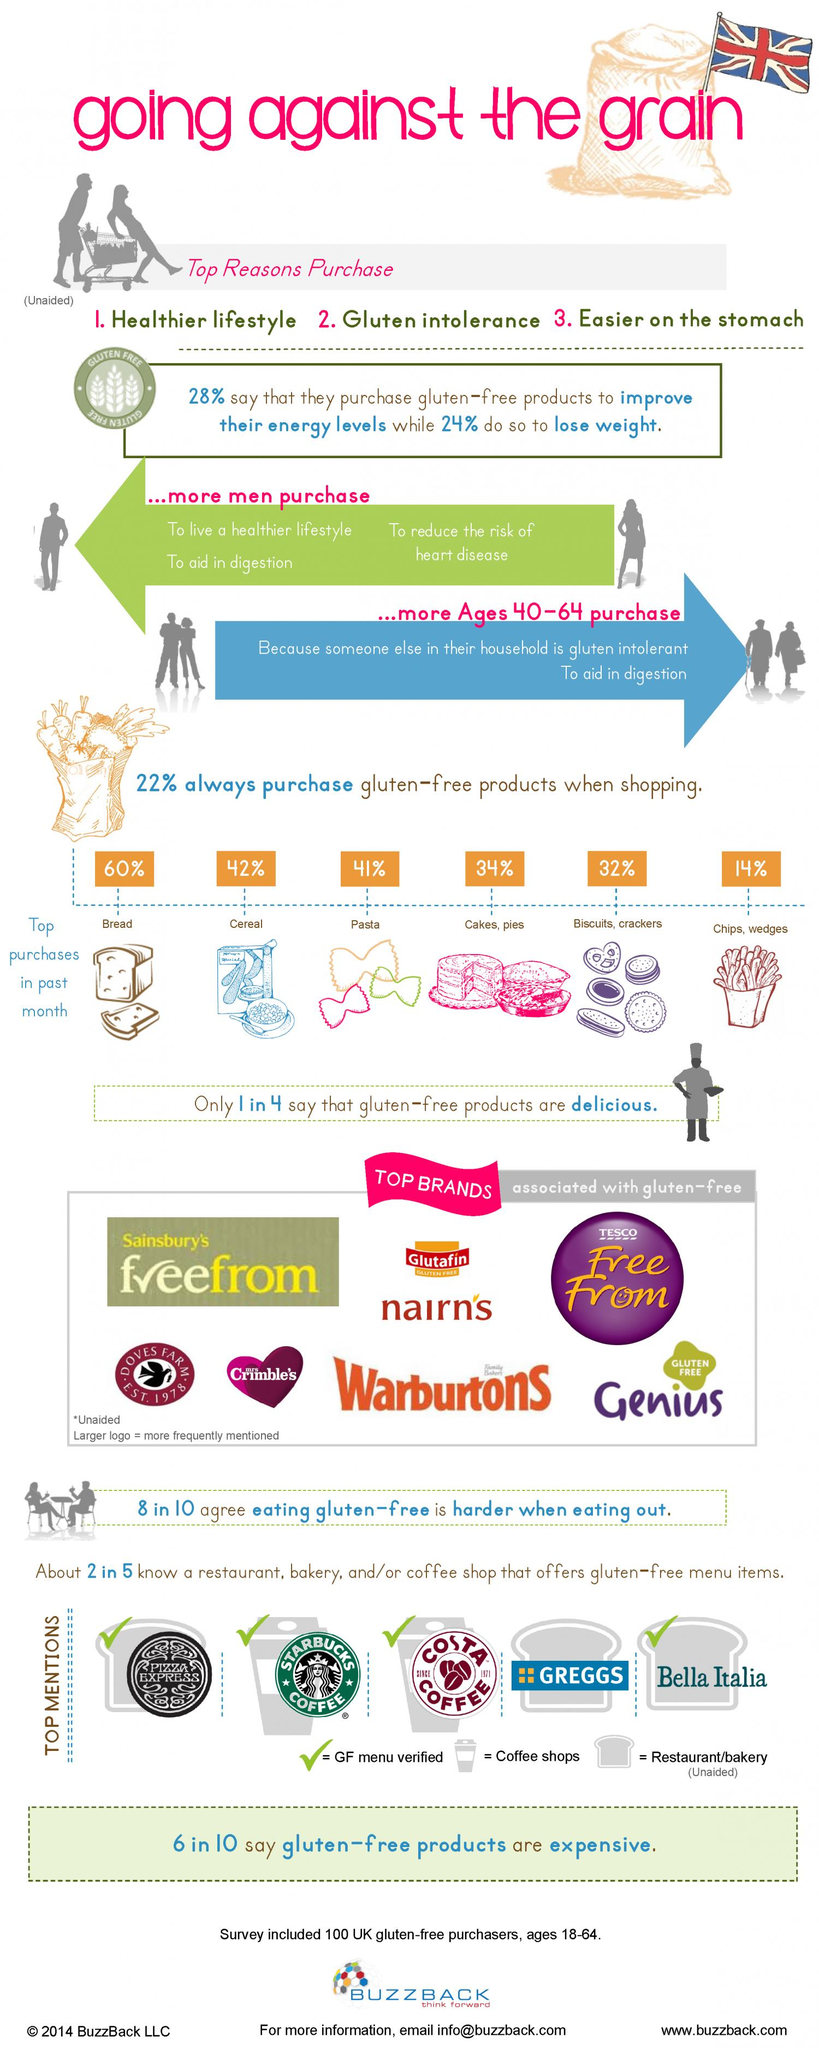Highlight a few significant elements in this photo. Glutafin is a brand that is less frequently mentioned as being gluten-free compared to other brands. The second most gluten-free product purchased is cereal. Sainsbury's and Tesco are two well-known brands that share the same name for their gluten-free products. 